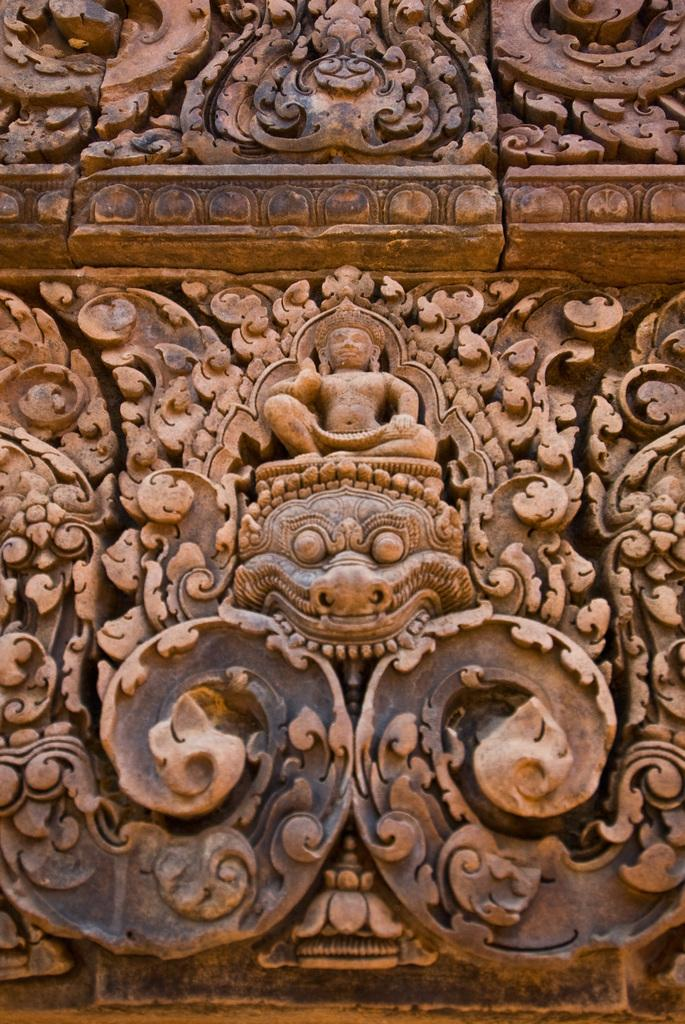What type of structure is visible in the image? There is a historical wall in the image. What can be seen on the wall? The wall has sculptures on it. What type of drink is being served in the morning at the wealthy person's house in the image? There is no information about drinks, morning, or wealth in the image; it only features a historical wall with sculptures on it. 